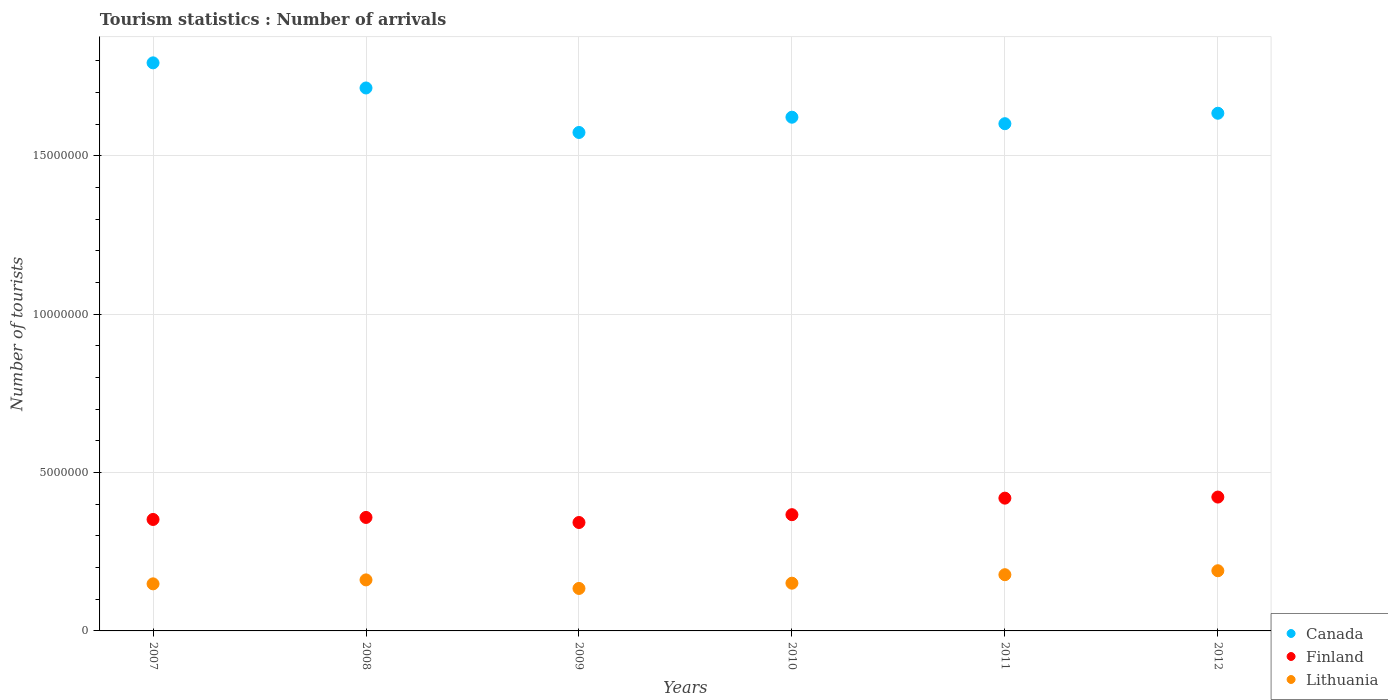What is the number of tourist arrivals in Finland in 2009?
Your answer should be very brief. 3.42e+06. Across all years, what is the maximum number of tourist arrivals in Finland?
Offer a very short reply. 4.23e+06. Across all years, what is the minimum number of tourist arrivals in Canada?
Give a very brief answer. 1.57e+07. In which year was the number of tourist arrivals in Finland maximum?
Give a very brief answer. 2012. What is the total number of tourist arrivals in Lithuania in the graph?
Offer a terse response. 9.62e+06. What is the difference between the number of tourist arrivals in Canada in 2007 and that in 2009?
Make the answer very short. 2.20e+06. What is the difference between the number of tourist arrivals in Lithuania in 2009 and the number of tourist arrivals in Finland in 2012?
Make the answer very short. -2.88e+06. What is the average number of tourist arrivals in Lithuania per year?
Your answer should be compact. 1.60e+06. In the year 2009, what is the difference between the number of tourist arrivals in Lithuania and number of tourist arrivals in Canada?
Keep it short and to the point. -1.44e+07. In how many years, is the number of tourist arrivals in Finland greater than 10000000?
Offer a very short reply. 0. What is the ratio of the number of tourist arrivals in Lithuania in 2010 to that in 2012?
Provide a succinct answer. 0.79. Is the number of tourist arrivals in Finland in 2007 less than that in 2011?
Ensure brevity in your answer.  Yes. What is the difference between the highest and the second highest number of tourist arrivals in Lithuania?
Your response must be concise. 1.25e+05. What is the difference between the highest and the lowest number of tourist arrivals in Lithuania?
Ensure brevity in your answer.  5.59e+05. In how many years, is the number of tourist arrivals in Finland greater than the average number of tourist arrivals in Finland taken over all years?
Provide a succinct answer. 2. Is the sum of the number of tourist arrivals in Canada in 2009 and 2012 greater than the maximum number of tourist arrivals in Finland across all years?
Provide a succinct answer. Yes. How many years are there in the graph?
Ensure brevity in your answer.  6. Are the values on the major ticks of Y-axis written in scientific E-notation?
Offer a very short reply. No. Does the graph contain any zero values?
Keep it short and to the point. No. How many legend labels are there?
Your answer should be compact. 3. How are the legend labels stacked?
Provide a succinct answer. Vertical. What is the title of the graph?
Provide a succinct answer. Tourism statistics : Number of arrivals. What is the label or title of the Y-axis?
Offer a very short reply. Number of tourists. What is the Number of tourists in Canada in 2007?
Make the answer very short. 1.79e+07. What is the Number of tourists in Finland in 2007?
Make the answer very short. 3.52e+06. What is the Number of tourists in Lithuania in 2007?
Provide a short and direct response. 1.49e+06. What is the Number of tourists of Canada in 2008?
Keep it short and to the point. 1.71e+07. What is the Number of tourists of Finland in 2008?
Offer a very short reply. 3.58e+06. What is the Number of tourists in Lithuania in 2008?
Give a very brief answer. 1.61e+06. What is the Number of tourists of Canada in 2009?
Your answer should be compact. 1.57e+07. What is the Number of tourists in Finland in 2009?
Make the answer very short. 3.42e+06. What is the Number of tourists of Lithuania in 2009?
Ensure brevity in your answer.  1.34e+06. What is the Number of tourists in Canada in 2010?
Offer a terse response. 1.62e+07. What is the Number of tourists of Finland in 2010?
Ensure brevity in your answer.  3.67e+06. What is the Number of tourists in Lithuania in 2010?
Give a very brief answer. 1.51e+06. What is the Number of tourists of Canada in 2011?
Offer a very short reply. 1.60e+07. What is the Number of tourists of Finland in 2011?
Make the answer very short. 4.19e+06. What is the Number of tourists in Lithuania in 2011?
Provide a short and direct response. 1.78e+06. What is the Number of tourists of Canada in 2012?
Give a very brief answer. 1.63e+07. What is the Number of tourists of Finland in 2012?
Give a very brief answer. 4.23e+06. What is the Number of tourists of Lithuania in 2012?
Keep it short and to the point. 1.90e+06. Across all years, what is the maximum Number of tourists of Canada?
Offer a terse response. 1.79e+07. Across all years, what is the maximum Number of tourists of Finland?
Offer a very short reply. 4.23e+06. Across all years, what is the maximum Number of tourists of Lithuania?
Your response must be concise. 1.90e+06. Across all years, what is the minimum Number of tourists of Canada?
Offer a terse response. 1.57e+07. Across all years, what is the minimum Number of tourists in Finland?
Your answer should be very brief. 3.42e+06. Across all years, what is the minimum Number of tourists in Lithuania?
Your response must be concise. 1.34e+06. What is the total Number of tourists in Canada in the graph?
Offer a very short reply. 9.94e+07. What is the total Number of tourists in Finland in the graph?
Provide a short and direct response. 2.26e+07. What is the total Number of tourists of Lithuania in the graph?
Provide a succinct answer. 9.62e+06. What is the difference between the Number of tourists in Canada in 2007 and that in 2008?
Offer a terse response. 7.93e+05. What is the difference between the Number of tourists in Finland in 2007 and that in 2008?
Your answer should be compact. -6.40e+04. What is the difference between the Number of tourists of Lithuania in 2007 and that in 2008?
Provide a short and direct response. -1.25e+05. What is the difference between the Number of tourists in Canada in 2007 and that in 2009?
Make the answer very short. 2.20e+06. What is the difference between the Number of tourists in Finland in 2007 and that in 2009?
Your answer should be very brief. 9.60e+04. What is the difference between the Number of tourists of Lithuania in 2007 and that in 2009?
Offer a very short reply. 1.45e+05. What is the difference between the Number of tourists of Canada in 2007 and that in 2010?
Provide a short and direct response. 1.72e+06. What is the difference between the Number of tourists of Finland in 2007 and that in 2010?
Ensure brevity in your answer.  -1.51e+05. What is the difference between the Number of tourists in Lithuania in 2007 and that in 2010?
Make the answer very short. -2.10e+04. What is the difference between the Number of tourists in Canada in 2007 and that in 2011?
Make the answer very short. 1.92e+06. What is the difference between the Number of tourists in Finland in 2007 and that in 2011?
Provide a succinct answer. -6.73e+05. What is the difference between the Number of tourists of Lithuania in 2007 and that in 2011?
Your answer should be very brief. -2.89e+05. What is the difference between the Number of tourists of Canada in 2007 and that in 2012?
Your answer should be compact. 1.59e+06. What is the difference between the Number of tourists in Finland in 2007 and that in 2012?
Make the answer very short. -7.07e+05. What is the difference between the Number of tourists in Lithuania in 2007 and that in 2012?
Give a very brief answer. -4.14e+05. What is the difference between the Number of tourists in Canada in 2008 and that in 2009?
Offer a terse response. 1.40e+06. What is the difference between the Number of tourists of Finland in 2008 and that in 2009?
Give a very brief answer. 1.60e+05. What is the difference between the Number of tourists of Canada in 2008 and that in 2010?
Offer a very short reply. 9.23e+05. What is the difference between the Number of tourists in Finland in 2008 and that in 2010?
Your answer should be compact. -8.70e+04. What is the difference between the Number of tourists of Lithuania in 2008 and that in 2010?
Make the answer very short. 1.04e+05. What is the difference between the Number of tourists of Canada in 2008 and that in 2011?
Provide a short and direct response. 1.13e+06. What is the difference between the Number of tourists of Finland in 2008 and that in 2011?
Your answer should be compact. -6.09e+05. What is the difference between the Number of tourists of Lithuania in 2008 and that in 2011?
Make the answer very short. -1.64e+05. What is the difference between the Number of tourists of Canada in 2008 and that in 2012?
Your answer should be very brief. 7.98e+05. What is the difference between the Number of tourists of Finland in 2008 and that in 2012?
Provide a succinct answer. -6.43e+05. What is the difference between the Number of tourists of Lithuania in 2008 and that in 2012?
Ensure brevity in your answer.  -2.89e+05. What is the difference between the Number of tourists of Canada in 2009 and that in 2010?
Ensure brevity in your answer.  -4.82e+05. What is the difference between the Number of tourists of Finland in 2009 and that in 2010?
Provide a succinct answer. -2.47e+05. What is the difference between the Number of tourists of Lithuania in 2009 and that in 2010?
Ensure brevity in your answer.  -1.66e+05. What is the difference between the Number of tourists in Canada in 2009 and that in 2011?
Make the answer very short. -2.77e+05. What is the difference between the Number of tourists in Finland in 2009 and that in 2011?
Provide a short and direct response. -7.69e+05. What is the difference between the Number of tourists in Lithuania in 2009 and that in 2011?
Provide a succinct answer. -4.34e+05. What is the difference between the Number of tourists of Canada in 2009 and that in 2012?
Your answer should be very brief. -6.07e+05. What is the difference between the Number of tourists of Finland in 2009 and that in 2012?
Give a very brief answer. -8.03e+05. What is the difference between the Number of tourists of Lithuania in 2009 and that in 2012?
Offer a very short reply. -5.59e+05. What is the difference between the Number of tourists of Canada in 2010 and that in 2011?
Your response must be concise. 2.05e+05. What is the difference between the Number of tourists of Finland in 2010 and that in 2011?
Your answer should be compact. -5.22e+05. What is the difference between the Number of tourists in Lithuania in 2010 and that in 2011?
Provide a succinct answer. -2.68e+05. What is the difference between the Number of tourists in Canada in 2010 and that in 2012?
Keep it short and to the point. -1.25e+05. What is the difference between the Number of tourists in Finland in 2010 and that in 2012?
Make the answer very short. -5.56e+05. What is the difference between the Number of tourists of Lithuania in 2010 and that in 2012?
Provide a succinct answer. -3.93e+05. What is the difference between the Number of tourists of Canada in 2011 and that in 2012?
Keep it short and to the point. -3.30e+05. What is the difference between the Number of tourists of Finland in 2011 and that in 2012?
Provide a short and direct response. -3.40e+04. What is the difference between the Number of tourists of Lithuania in 2011 and that in 2012?
Make the answer very short. -1.25e+05. What is the difference between the Number of tourists of Canada in 2007 and the Number of tourists of Finland in 2008?
Make the answer very short. 1.44e+07. What is the difference between the Number of tourists in Canada in 2007 and the Number of tourists in Lithuania in 2008?
Make the answer very short. 1.63e+07. What is the difference between the Number of tourists of Finland in 2007 and the Number of tourists of Lithuania in 2008?
Provide a succinct answer. 1.91e+06. What is the difference between the Number of tourists in Canada in 2007 and the Number of tourists in Finland in 2009?
Provide a succinct answer. 1.45e+07. What is the difference between the Number of tourists of Canada in 2007 and the Number of tourists of Lithuania in 2009?
Provide a short and direct response. 1.66e+07. What is the difference between the Number of tourists of Finland in 2007 and the Number of tourists of Lithuania in 2009?
Your answer should be very brief. 2.18e+06. What is the difference between the Number of tourists of Canada in 2007 and the Number of tourists of Finland in 2010?
Offer a very short reply. 1.43e+07. What is the difference between the Number of tourists of Canada in 2007 and the Number of tourists of Lithuania in 2010?
Offer a very short reply. 1.64e+07. What is the difference between the Number of tourists of Finland in 2007 and the Number of tourists of Lithuania in 2010?
Ensure brevity in your answer.  2.01e+06. What is the difference between the Number of tourists of Canada in 2007 and the Number of tourists of Finland in 2011?
Offer a very short reply. 1.37e+07. What is the difference between the Number of tourists of Canada in 2007 and the Number of tourists of Lithuania in 2011?
Ensure brevity in your answer.  1.62e+07. What is the difference between the Number of tourists in Finland in 2007 and the Number of tourists in Lithuania in 2011?
Make the answer very short. 1.74e+06. What is the difference between the Number of tourists of Canada in 2007 and the Number of tourists of Finland in 2012?
Provide a succinct answer. 1.37e+07. What is the difference between the Number of tourists in Canada in 2007 and the Number of tourists in Lithuania in 2012?
Give a very brief answer. 1.60e+07. What is the difference between the Number of tourists of Finland in 2007 and the Number of tourists of Lithuania in 2012?
Provide a short and direct response. 1.62e+06. What is the difference between the Number of tourists of Canada in 2008 and the Number of tourists of Finland in 2009?
Provide a succinct answer. 1.37e+07. What is the difference between the Number of tourists in Canada in 2008 and the Number of tourists in Lithuania in 2009?
Ensure brevity in your answer.  1.58e+07. What is the difference between the Number of tourists of Finland in 2008 and the Number of tourists of Lithuania in 2009?
Provide a short and direct response. 2.24e+06. What is the difference between the Number of tourists in Canada in 2008 and the Number of tourists in Finland in 2010?
Offer a very short reply. 1.35e+07. What is the difference between the Number of tourists in Canada in 2008 and the Number of tourists in Lithuania in 2010?
Your answer should be very brief. 1.56e+07. What is the difference between the Number of tourists of Finland in 2008 and the Number of tourists of Lithuania in 2010?
Provide a succinct answer. 2.08e+06. What is the difference between the Number of tourists in Canada in 2008 and the Number of tourists in Finland in 2011?
Offer a very short reply. 1.30e+07. What is the difference between the Number of tourists in Canada in 2008 and the Number of tourists in Lithuania in 2011?
Provide a short and direct response. 1.54e+07. What is the difference between the Number of tourists in Finland in 2008 and the Number of tourists in Lithuania in 2011?
Make the answer very short. 1.81e+06. What is the difference between the Number of tourists of Canada in 2008 and the Number of tourists of Finland in 2012?
Your response must be concise. 1.29e+07. What is the difference between the Number of tourists in Canada in 2008 and the Number of tourists in Lithuania in 2012?
Your answer should be compact. 1.52e+07. What is the difference between the Number of tourists in Finland in 2008 and the Number of tourists in Lithuania in 2012?
Ensure brevity in your answer.  1.68e+06. What is the difference between the Number of tourists of Canada in 2009 and the Number of tourists of Finland in 2010?
Your answer should be very brief. 1.21e+07. What is the difference between the Number of tourists of Canada in 2009 and the Number of tourists of Lithuania in 2010?
Ensure brevity in your answer.  1.42e+07. What is the difference between the Number of tourists of Finland in 2009 and the Number of tourists of Lithuania in 2010?
Offer a terse response. 1.92e+06. What is the difference between the Number of tourists in Canada in 2009 and the Number of tourists in Finland in 2011?
Give a very brief answer. 1.15e+07. What is the difference between the Number of tourists of Canada in 2009 and the Number of tourists of Lithuania in 2011?
Make the answer very short. 1.40e+07. What is the difference between the Number of tourists of Finland in 2009 and the Number of tourists of Lithuania in 2011?
Provide a short and direct response. 1.65e+06. What is the difference between the Number of tourists in Canada in 2009 and the Number of tourists in Finland in 2012?
Offer a very short reply. 1.15e+07. What is the difference between the Number of tourists in Canada in 2009 and the Number of tourists in Lithuania in 2012?
Provide a short and direct response. 1.38e+07. What is the difference between the Number of tourists in Finland in 2009 and the Number of tourists in Lithuania in 2012?
Provide a succinct answer. 1.52e+06. What is the difference between the Number of tourists of Canada in 2010 and the Number of tourists of Finland in 2011?
Your response must be concise. 1.20e+07. What is the difference between the Number of tourists of Canada in 2010 and the Number of tourists of Lithuania in 2011?
Your answer should be very brief. 1.44e+07. What is the difference between the Number of tourists in Finland in 2010 and the Number of tourists in Lithuania in 2011?
Your answer should be compact. 1.90e+06. What is the difference between the Number of tourists of Canada in 2010 and the Number of tourists of Finland in 2012?
Your answer should be compact. 1.20e+07. What is the difference between the Number of tourists of Canada in 2010 and the Number of tourists of Lithuania in 2012?
Offer a terse response. 1.43e+07. What is the difference between the Number of tourists of Finland in 2010 and the Number of tourists of Lithuania in 2012?
Give a very brief answer. 1.77e+06. What is the difference between the Number of tourists of Canada in 2011 and the Number of tourists of Finland in 2012?
Offer a very short reply. 1.18e+07. What is the difference between the Number of tourists in Canada in 2011 and the Number of tourists in Lithuania in 2012?
Ensure brevity in your answer.  1.41e+07. What is the difference between the Number of tourists in Finland in 2011 and the Number of tourists in Lithuania in 2012?
Offer a very short reply. 2.29e+06. What is the average Number of tourists in Canada per year?
Provide a succinct answer. 1.66e+07. What is the average Number of tourists in Finland per year?
Make the answer very short. 3.77e+06. What is the average Number of tourists in Lithuania per year?
Offer a terse response. 1.60e+06. In the year 2007, what is the difference between the Number of tourists in Canada and Number of tourists in Finland?
Make the answer very short. 1.44e+07. In the year 2007, what is the difference between the Number of tourists of Canada and Number of tourists of Lithuania?
Offer a terse response. 1.64e+07. In the year 2007, what is the difference between the Number of tourists in Finland and Number of tourists in Lithuania?
Your answer should be very brief. 2.03e+06. In the year 2008, what is the difference between the Number of tourists of Canada and Number of tourists of Finland?
Your answer should be compact. 1.36e+07. In the year 2008, what is the difference between the Number of tourists in Canada and Number of tourists in Lithuania?
Your answer should be very brief. 1.55e+07. In the year 2008, what is the difference between the Number of tourists in Finland and Number of tourists in Lithuania?
Provide a succinct answer. 1.97e+06. In the year 2009, what is the difference between the Number of tourists of Canada and Number of tourists of Finland?
Your answer should be very brief. 1.23e+07. In the year 2009, what is the difference between the Number of tourists in Canada and Number of tourists in Lithuania?
Keep it short and to the point. 1.44e+07. In the year 2009, what is the difference between the Number of tourists in Finland and Number of tourists in Lithuania?
Give a very brief answer. 2.08e+06. In the year 2010, what is the difference between the Number of tourists in Canada and Number of tourists in Finland?
Your response must be concise. 1.25e+07. In the year 2010, what is the difference between the Number of tourists of Canada and Number of tourists of Lithuania?
Make the answer very short. 1.47e+07. In the year 2010, what is the difference between the Number of tourists in Finland and Number of tourists in Lithuania?
Your answer should be very brief. 2.16e+06. In the year 2011, what is the difference between the Number of tourists of Canada and Number of tourists of Finland?
Provide a short and direct response. 1.18e+07. In the year 2011, what is the difference between the Number of tourists of Canada and Number of tourists of Lithuania?
Ensure brevity in your answer.  1.42e+07. In the year 2011, what is the difference between the Number of tourists in Finland and Number of tourists in Lithuania?
Provide a succinct answer. 2.42e+06. In the year 2012, what is the difference between the Number of tourists of Canada and Number of tourists of Finland?
Provide a succinct answer. 1.21e+07. In the year 2012, what is the difference between the Number of tourists of Canada and Number of tourists of Lithuania?
Give a very brief answer. 1.44e+07. In the year 2012, what is the difference between the Number of tourists in Finland and Number of tourists in Lithuania?
Provide a short and direct response. 2.33e+06. What is the ratio of the Number of tourists of Canada in 2007 to that in 2008?
Provide a short and direct response. 1.05. What is the ratio of the Number of tourists of Finland in 2007 to that in 2008?
Your response must be concise. 0.98. What is the ratio of the Number of tourists in Lithuania in 2007 to that in 2008?
Provide a succinct answer. 0.92. What is the ratio of the Number of tourists in Canada in 2007 to that in 2009?
Keep it short and to the point. 1.14. What is the ratio of the Number of tourists in Finland in 2007 to that in 2009?
Ensure brevity in your answer.  1.03. What is the ratio of the Number of tourists of Lithuania in 2007 to that in 2009?
Keep it short and to the point. 1.11. What is the ratio of the Number of tourists in Canada in 2007 to that in 2010?
Your answer should be compact. 1.11. What is the ratio of the Number of tourists in Finland in 2007 to that in 2010?
Offer a terse response. 0.96. What is the ratio of the Number of tourists in Lithuania in 2007 to that in 2010?
Keep it short and to the point. 0.99. What is the ratio of the Number of tourists of Canada in 2007 to that in 2011?
Your response must be concise. 1.12. What is the ratio of the Number of tourists of Finland in 2007 to that in 2011?
Provide a short and direct response. 0.84. What is the ratio of the Number of tourists of Lithuania in 2007 to that in 2011?
Provide a short and direct response. 0.84. What is the ratio of the Number of tourists of Canada in 2007 to that in 2012?
Ensure brevity in your answer.  1.1. What is the ratio of the Number of tourists of Finland in 2007 to that in 2012?
Your answer should be compact. 0.83. What is the ratio of the Number of tourists in Lithuania in 2007 to that in 2012?
Offer a very short reply. 0.78. What is the ratio of the Number of tourists in Canada in 2008 to that in 2009?
Keep it short and to the point. 1.09. What is the ratio of the Number of tourists of Finland in 2008 to that in 2009?
Your answer should be compact. 1.05. What is the ratio of the Number of tourists in Lithuania in 2008 to that in 2009?
Make the answer very short. 1.2. What is the ratio of the Number of tourists of Canada in 2008 to that in 2010?
Keep it short and to the point. 1.06. What is the ratio of the Number of tourists in Finland in 2008 to that in 2010?
Your answer should be very brief. 0.98. What is the ratio of the Number of tourists of Lithuania in 2008 to that in 2010?
Your answer should be compact. 1.07. What is the ratio of the Number of tourists of Canada in 2008 to that in 2011?
Keep it short and to the point. 1.07. What is the ratio of the Number of tourists in Finland in 2008 to that in 2011?
Your answer should be very brief. 0.85. What is the ratio of the Number of tourists of Lithuania in 2008 to that in 2011?
Provide a succinct answer. 0.91. What is the ratio of the Number of tourists of Canada in 2008 to that in 2012?
Your answer should be very brief. 1.05. What is the ratio of the Number of tourists of Finland in 2008 to that in 2012?
Give a very brief answer. 0.85. What is the ratio of the Number of tourists of Lithuania in 2008 to that in 2012?
Give a very brief answer. 0.85. What is the ratio of the Number of tourists of Canada in 2009 to that in 2010?
Your answer should be compact. 0.97. What is the ratio of the Number of tourists in Finland in 2009 to that in 2010?
Offer a very short reply. 0.93. What is the ratio of the Number of tourists of Lithuania in 2009 to that in 2010?
Your answer should be very brief. 0.89. What is the ratio of the Number of tourists in Canada in 2009 to that in 2011?
Offer a terse response. 0.98. What is the ratio of the Number of tourists in Finland in 2009 to that in 2011?
Your answer should be very brief. 0.82. What is the ratio of the Number of tourists in Lithuania in 2009 to that in 2011?
Your response must be concise. 0.76. What is the ratio of the Number of tourists in Canada in 2009 to that in 2012?
Your answer should be very brief. 0.96. What is the ratio of the Number of tourists in Finland in 2009 to that in 2012?
Ensure brevity in your answer.  0.81. What is the ratio of the Number of tourists in Lithuania in 2009 to that in 2012?
Your response must be concise. 0.71. What is the ratio of the Number of tourists in Canada in 2010 to that in 2011?
Offer a terse response. 1.01. What is the ratio of the Number of tourists of Finland in 2010 to that in 2011?
Ensure brevity in your answer.  0.88. What is the ratio of the Number of tourists of Lithuania in 2010 to that in 2011?
Your answer should be very brief. 0.85. What is the ratio of the Number of tourists in Finland in 2010 to that in 2012?
Offer a terse response. 0.87. What is the ratio of the Number of tourists of Lithuania in 2010 to that in 2012?
Provide a succinct answer. 0.79. What is the ratio of the Number of tourists in Canada in 2011 to that in 2012?
Ensure brevity in your answer.  0.98. What is the ratio of the Number of tourists in Lithuania in 2011 to that in 2012?
Keep it short and to the point. 0.93. What is the difference between the highest and the second highest Number of tourists in Canada?
Provide a short and direct response. 7.93e+05. What is the difference between the highest and the second highest Number of tourists of Finland?
Your answer should be compact. 3.40e+04. What is the difference between the highest and the second highest Number of tourists in Lithuania?
Offer a terse response. 1.25e+05. What is the difference between the highest and the lowest Number of tourists of Canada?
Provide a short and direct response. 2.20e+06. What is the difference between the highest and the lowest Number of tourists of Finland?
Keep it short and to the point. 8.03e+05. What is the difference between the highest and the lowest Number of tourists in Lithuania?
Give a very brief answer. 5.59e+05. 